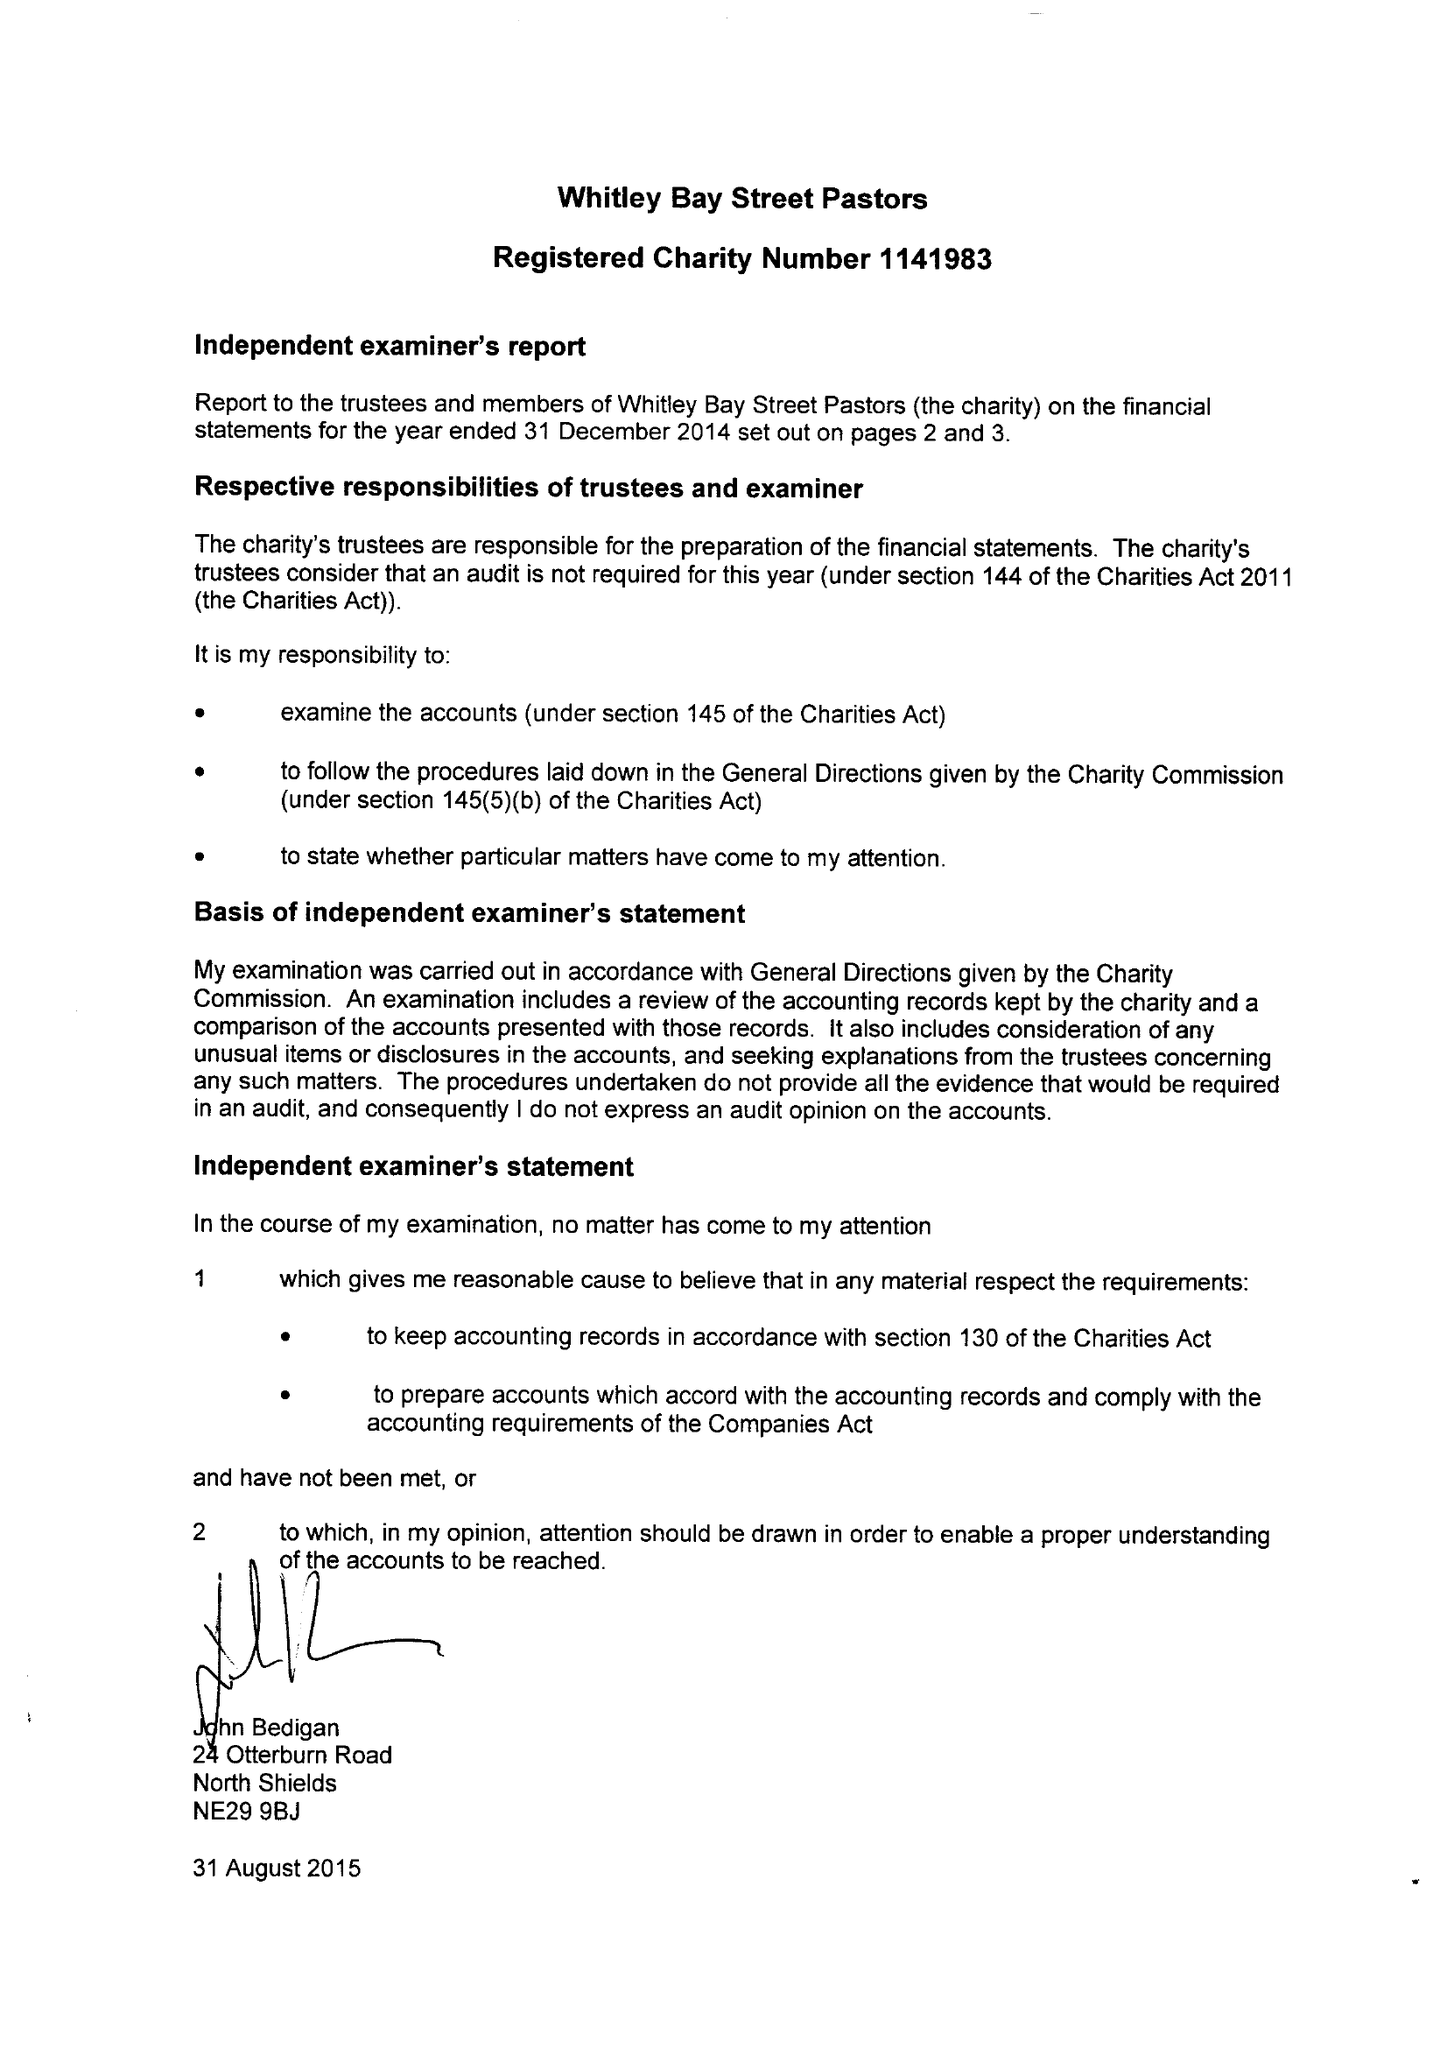What is the value for the report_date?
Answer the question using a single word or phrase. 2014-12-31 